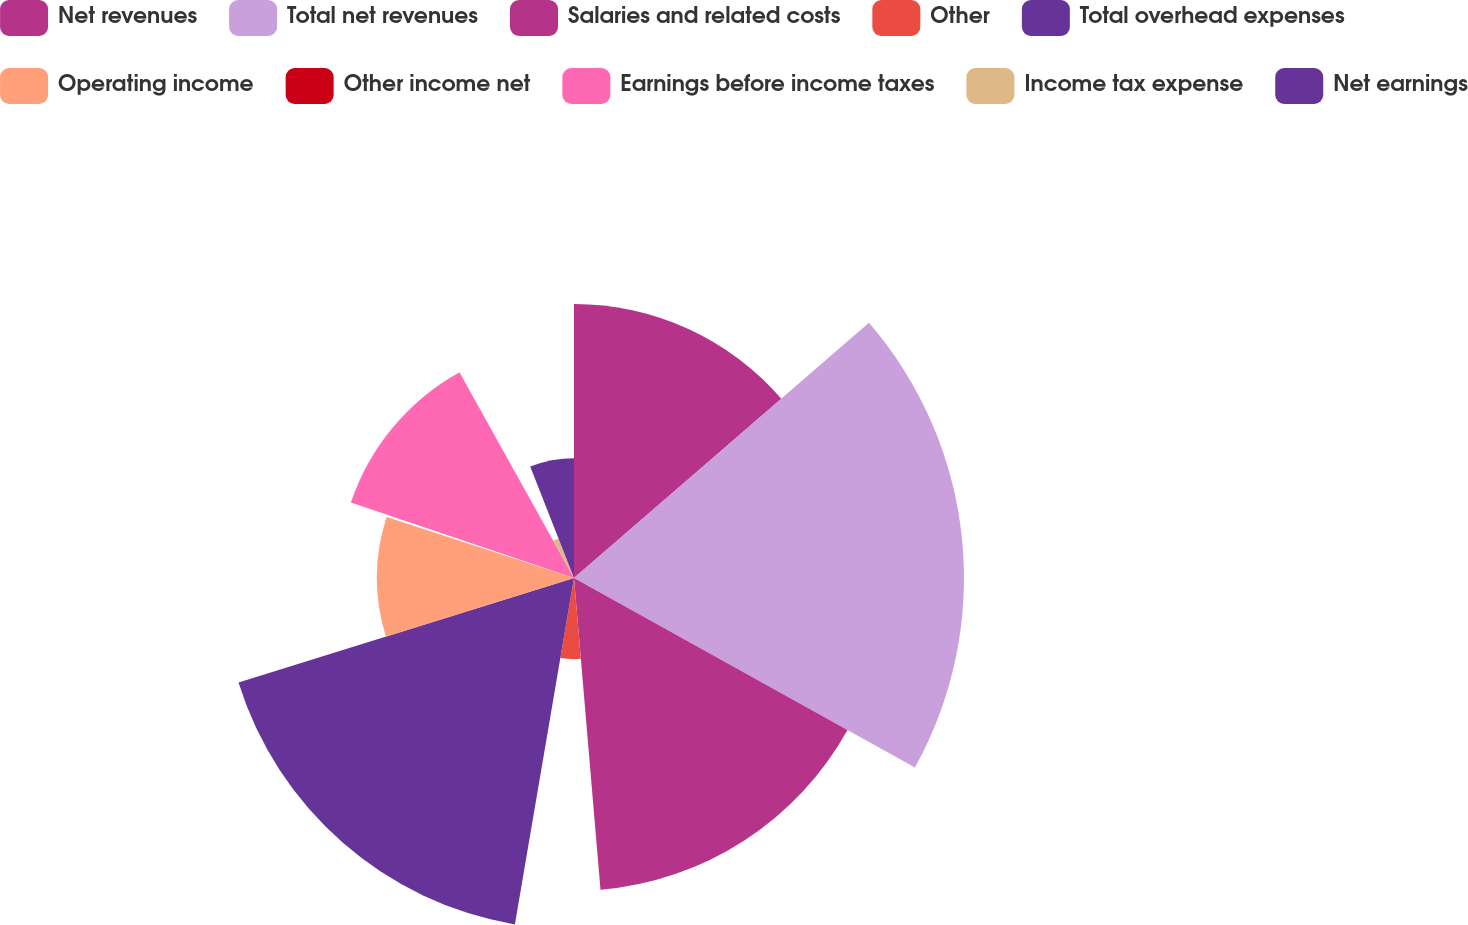<chart> <loc_0><loc_0><loc_500><loc_500><pie_chart><fcel>Net revenues<fcel>Total net revenues<fcel>Salaries and related costs<fcel>Other<fcel>Total overhead expenses<fcel>Operating income<fcel>Other income net<fcel>Earnings before income taxes<fcel>Income tax expense<fcel>Net earnings<nl><fcel>13.65%<fcel>19.42%<fcel>15.58%<fcel>4.04%<fcel>17.5%<fcel>9.81%<fcel>0.19%<fcel>11.73%<fcel>2.12%<fcel>5.96%<nl></chart> 